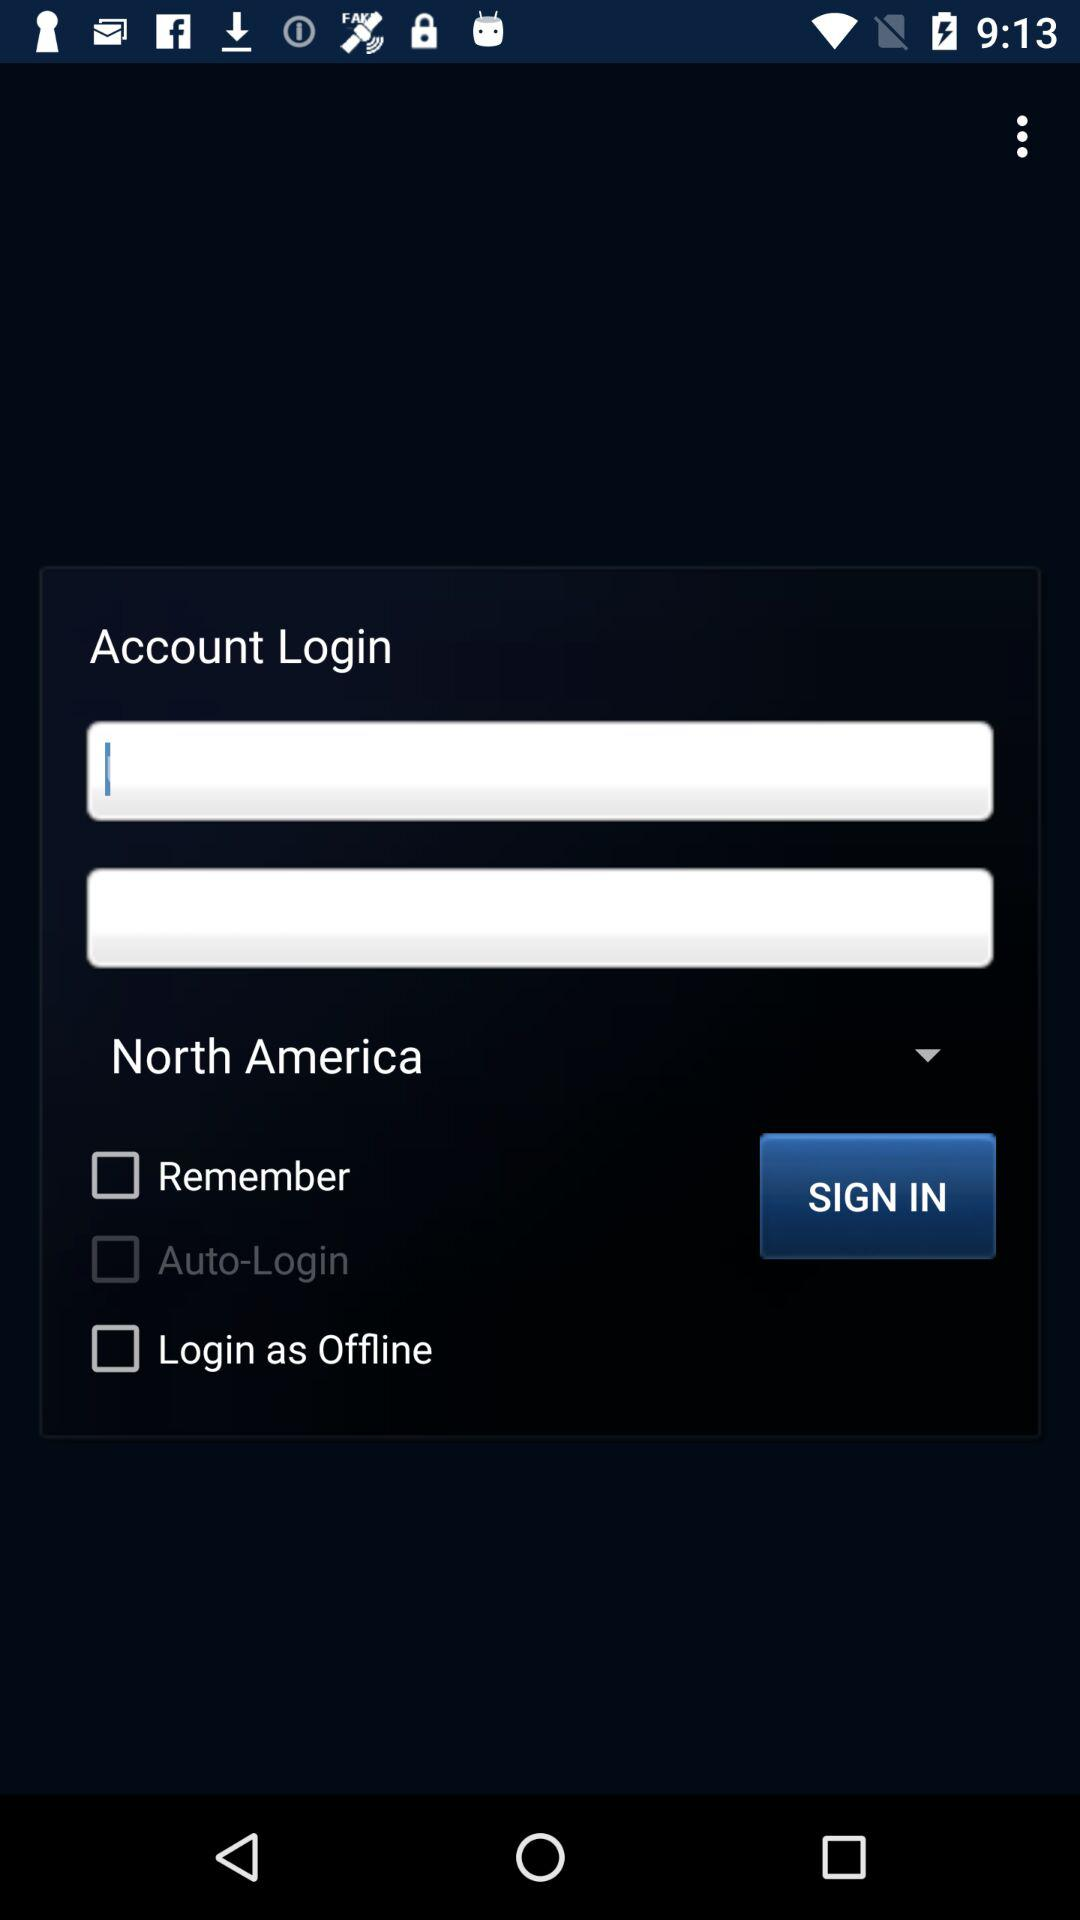What is the status of "Login as Offline"? The status of "Login as Offline" is "off". 